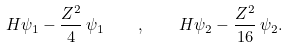Convert formula to latex. <formula><loc_0><loc_0><loc_500><loc_500>H \psi _ { 1 } - \frac { Z ^ { 2 } } { 4 } \, \psi _ { 1 } \quad , \quad H \psi _ { 2 } - \frac { Z ^ { 2 } } { 1 6 } \, \psi _ { 2 } .</formula> 